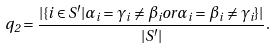<formula> <loc_0><loc_0><loc_500><loc_500>q _ { 2 } = \frac { | \{ i \in S ^ { \prime } | \alpha _ { i } = \gamma _ { i } \neq \beta _ { i } o r \alpha _ { i } = \beta _ { i } \neq \gamma _ { i } \} | } { | S ^ { \prime } | } .</formula> 